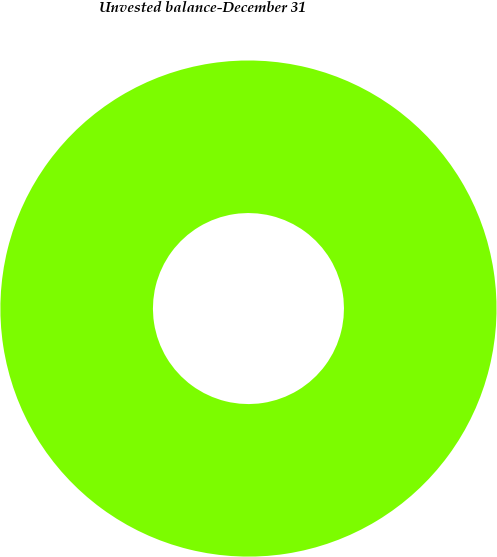<chart> <loc_0><loc_0><loc_500><loc_500><pie_chart><fcel>Unvested balance-December 31<nl><fcel>100.0%<nl></chart> 